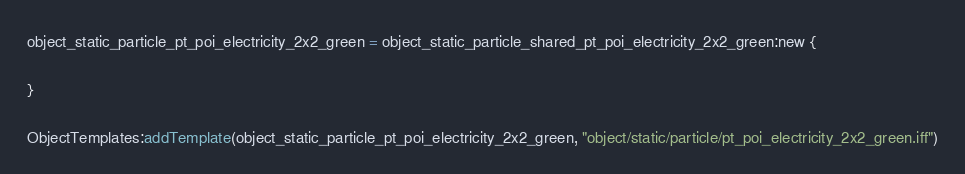<code> <loc_0><loc_0><loc_500><loc_500><_Lua_>object_static_particle_pt_poi_electricity_2x2_green = object_static_particle_shared_pt_poi_electricity_2x2_green:new {

}

ObjectTemplates:addTemplate(object_static_particle_pt_poi_electricity_2x2_green, "object/static/particle/pt_poi_electricity_2x2_green.iff")
</code> 